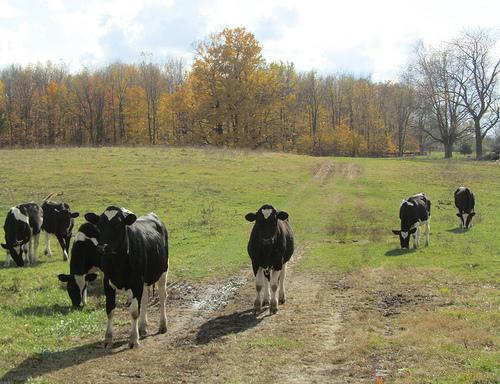Mention the main subject and the environment they are in. The main subject is a group of black and white cows in a pasture with trees, grass, puddles, and a cloudy blue sky. Combine all the major aspects of the image into a single brief description. The image displays black and white cows in a rural setting with a mixture of green and yellowing trees, dirt tracks, grass, and puddles under a cloudy blue sky. In one sentence, describe the primary elements of the picture. Black and white cows graze in a pasture with bare and yellowing trees, sparse grass, dirt tracks, and pools of water under a cloudy sky. Explain what the cows are doing and the area they are in briefly. The cows are grazing and walking in a field with patches of dirt, puddles, sparse grass, and trees with yellow and brown leaves. Describe the overall atmosphere and setting of the image. The image presents a serene rural scene with cows grazing in a grassy field, dotted with dirt tracks, puddles, and trees displaying autumn colors, all beneath a cloud-filled sky. List the main elements found in the image in one sentence. A herd of black and white cows grazing on sparse grass, surrounded by trees with yellow and brown leaves, under a cloudy blue sky. Concisely describe the surroundings and actions in the image. Cows are grazing and moving around in a field with dirt paths, puddles, sparse grass, and trees with bare branches and yellow leaves. Highlight the main components of the image in a concise manner. Cows grazing, dirt tracks, green and yellow trees, puddles, cloudy sky. Provide a brief summary of the scene portrayed in the image. The image shows a group of black and white cows grazing in a field with patches of dirt, puddles, and sparse grass, while surrounded by trees with yellow leaves and a cloudy blue sky. In a short sentence, mention the main focus of the image and its environment. The image focuses on cows grazing in a field with autumn trees, patches of sparse grass, and cloudy sky overhead. 